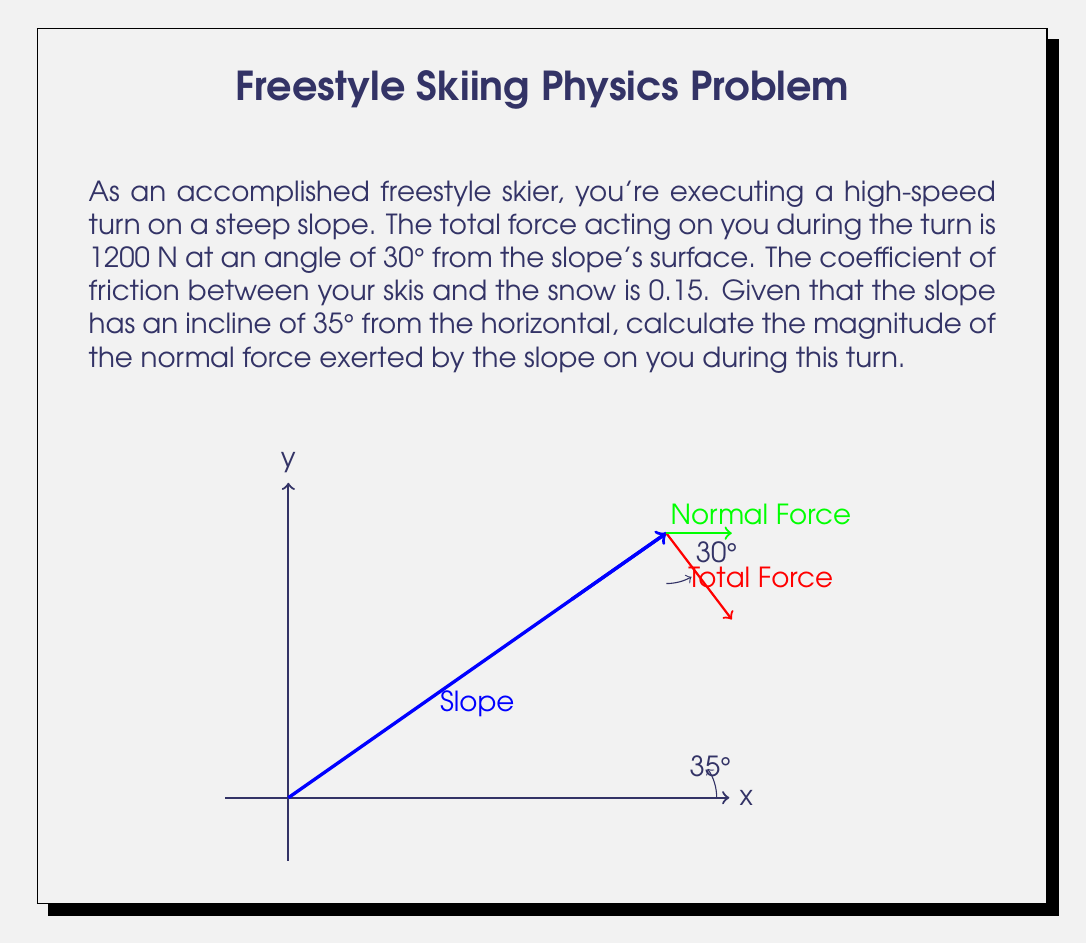Solve this math problem. Let's approach this step-by-step:

1) First, we need to identify the forces acting on the skier:
   - Normal force (N) perpendicular to the slope
   - Friction force (f) parallel to the slope
   - Gravity (mg) acting downward
   - Total force (F) at 30° from the slope

2) We can break down the total force into components parallel and perpendicular to the slope:
   $F_\parallel = F \cos 30° = 1200 \cos 30°$
   $F_\perp = F \sin 30° = 1200 \sin 30°$

3) The normal force (N) is equal to the perpendicular component of the total force plus the perpendicular component of gravity:
   $N = F_\perp + mg \cos 35°$

4) We don't know the mass, but we can relate it to the friction force:
   $f = \mu N = 0.15N$

5) The parallel component of the total force must equal the sum of the parallel component of gravity and the friction force:
   $F_\parallel = mg \sin 35° + f = mg \sin 35° + 0.15N$

6) Now we have two equations and two unknowns (m and N):
   $N = 1200 \sin 30° + mg \cos 35°$
   $1200 \cos 30° = mg \sin 35° + 0.15N$

7) Substituting the first equation into the second:
   $1200 \cos 30° = mg \sin 35° + 0.15(1200 \sin 30° + mg \cos 35°)$

8) Simplifying and solving for mg:
   $mg = \frac{1200 \cos 30° - 180 \sin 30°}{\sin 35° + 0.15 \cos 35°} \approx 1034.48$

9) Finally, we can calculate N:
   $N = 1200 \sin 30° + 1034.48 \cos 35° \approx 1445.96$ N
Answer: $1446$ N 